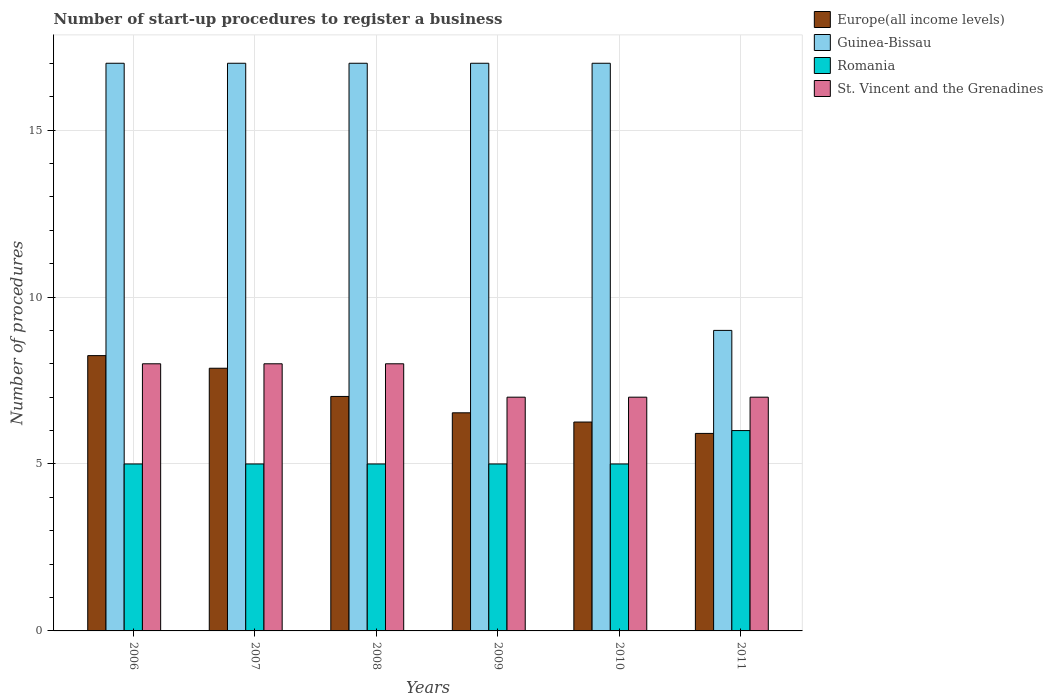How many groups of bars are there?
Provide a succinct answer. 6. Are the number of bars per tick equal to the number of legend labels?
Offer a terse response. Yes. How many bars are there on the 3rd tick from the left?
Make the answer very short. 4. In how many cases, is the number of bars for a given year not equal to the number of legend labels?
Offer a very short reply. 0. Across all years, what is the minimum number of procedures required to register a business in St. Vincent and the Grenadines?
Your answer should be very brief. 7. In which year was the number of procedures required to register a business in Europe(all income levels) maximum?
Make the answer very short. 2006. In which year was the number of procedures required to register a business in Romania minimum?
Your response must be concise. 2006. What is the difference between the number of procedures required to register a business in St. Vincent and the Grenadines in 2007 and that in 2009?
Your answer should be very brief. 1. What is the difference between the number of procedures required to register a business in Guinea-Bissau in 2007 and the number of procedures required to register a business in Europe(all income levels) in 2011?
Offer a terse response. 11.09. What is the average number of procedures required to register a business in Romania per year?
Offer a very short reply. 5.17. In the year 2007, what is the difference between the number of procedures required to register a business in Romania and number of procedures required to register a business in Europe(all income levels)?
Provide a succinct answer. -2.87. In how many years, is the number of procedures required to register a business in Romania greater than 8?
Offer a terse response. 0. What is the ratio of the number of procedures required to register a business in Romania in 2009 to that in 2011?
Keep it short and to the point. 0.83. What is the difference between the highest and the second highest number of procedures required to register a business in Europe(all income levels)?
Offer a terse response. 0.38. In how many years, is the number of procedures required to register a business in Europe(all income levels) greater than the average number of procedures required to register a business in Europe(all income levels) taken over all years?
Your response must be concise. 3. Is it the case that in every year, the sum of the number of procedures required to register a business in Europe(all income levels) and number of procedures required to register a business in Romania is greater than the sum of number of procedures required to register a business in Guinea-Bissau and number of procedures required to register a business in St. Vincent and the Grenadines?
Give a very brief answer. No. What does the 4th bar from the left in 2011 represents?
Your response must be concise. St. Vincent and the Grenadines. What does the 4th bar from the right in 2009 represents?
Offer a terse response. Europe(all income levels). Is it the case that in every year, the sum of the number of procedures required to register a business in Guinea-Bissau and number of procedures required to register a business in Romania is greater than the number of procedures required to register a business in Europe(all income levels)?
Your answer should be very brief. Yes. How many bars are there?
Make the answer very short. 24. What is the difference between two consecutive major ticks on the Y-axis?
Keep it short and to the point. 5. How many legend labels are there?
Give a very brief answer. 4. What is the title of the graph?
Provide a short and direct response. Number of start-up procedures to register a business. Does "Kazakhstan" appear as one of the legend labels in the graph?
Make the answer very short. No. What is the label or title of the Y-axis?
Offer a very short reply. Number of procedures. What is the Number of procedures of Europe(all income levels) in 2006?
Make the answer very short. 8.24. What is the Number of procedures of Romania in 2006?
Give a very brief answer. 5. What is the Number of procedures of Europe(all income levels) in 2007?
Make the answer very short. 7.87. What is the Number of procedures of Guinea-Bissau in 2007?
Give a very brief answer. 17. What is the Number of procedures in St. Vincent and the Grenadines in 2007?
Your answer should be compact. 8. What is the Number of procedures in Europe(all income levels) in 2008?
Keep it short and to the point. 7.02. What is the Number of procedures in Guinea-Bissau in 2008?
Ensure brevity in your answer.  17. What is the Number of procedures of St. Vincent and the Grenadines in 2008?
Provide a short and direct response. 8. What is the Number of procedures of Europe(all income levels) in 2009?
Ensure brevity in your answer.  6.53. What is the Number of procedures in Romania in 2009?
Ensure brevity in your answer.  5. What is the Number of procedures of Europe(all income levels) in 2010?
Your response must be concise. 6.26. What is the Number of procedures of Europe(all income levels) in 2011?
Give a very brief answer. 5.91. What is the Number of procedures of Guinea-Bissau in 2011?
Ensure brevity in your answer.  9. What is the Number of procedures in St. Vincent and the Grenadines in 2011?
Ensure brevity in your answer.  7. Across all years, what is the maximum Number of procedures of Europe(all income levels)?
Offer a terse response. 8.24. Across all years, what is the minimum Number of procedures in Europe(all income levels)?
Make the answer very short. 5.91. Across all years, what is the minimum Number of procedures in Romania?
Your answer should be very brief. 5. What is the total Number of procedures in Europe(all income levels) in the graph?
Provide a short and direct response. 41.84. What is the total Number of procedures in Guinea-Bissau in the graph?
Your answer should be very brief. 94. What is the total Number of procedures of St. Vincent and the Grenadines in the graph?
Keep it short and to the point. 45. What is the difference between the Number of procedures of Europe(all income levels) in 2006 and that in 2007?
Your response must be concise. 0.38. What is the difference between the Number of procedures of Guinea-Bissau in 2006 and that in 2007?
Your answer should be compact. 0. What is the difference between the Number of procedures of Romania in 2006 and that in 2007?
Your answer should be compact. 0. What is the difference between the Number of procedures in Europe(all income levels) in 2006 and that in 2008?
Offer a terse response. 1.22. What is the difference between the Number of procedures of St. Vincent and the Grenadines in 2006 and that in 2008?
Make the answer very short. 0. What is the difference between the Number of procedures in Europe(all income levels) in 2006 and that in 2009?
Make the answer very short. 1.71. What is the difference between the Number of procedures of Romania in 2006 and that in 2009?
Your answer should be compact. 0. What is the difference between the Number of procedures in Europe(all income levels) in 2006 and that in 2010?
Provide a short and direct response. 1.99. What is the difference between the Number of procedures in Romania in 2006 and that in 2010?
Ensure brevity in your answer.  0. What is the difference between the Number of procedures in St. Vincent and the Grenadines in 2006 and that in 2010?
Your answer should be compact. 1. What is the difference between the Number of procedures in Europe(all income levels) in 2006 and that in 2011?
Provide a short and direct response. 2.33. What is the difference between the Number of procedures of Romania in 2006 and that in 2011?
Your answer should be compact. -1. What is the difference between the Number of procedures of Europe(all income levels) in 2007 and that in 2008?
Your answer should be compact. 0.84. What is the difference between the Number of procedures in Guinea-Bissau in 2007 and that in 2008?
Your answer should be very brief. 0. What is the difference between the Number of procedures of Romania in 2007 and that in 2008?
Keep it short and to the point. 0. What is the difference between the Number of procedures in St. Vincent and the Grenadines in 2007 and that in 2008?
Provide a succinct answer. 0. What is the difference between the Number of procedures in Europe(all income levels) in 2007 and that in 2009?
Provide a short and direct response. 1.33. What is the difference between the Number of procedures of Guinea-Bissau in 2007 and that in 2009?
Offer a terse response. 0. What is the difference between the Number of procedures of Romania in 2007 and that in 2009?
Offer a very short reply. 0. What is the difference between the Number of procedures of Europe(all income levels) in 2007 and that in 2010?
Make the answer very short. 1.61. What is the difference between the Number of procedures of Europe(all income levels) in 2007 and that in 2011?
Offer a very short reply. 1.95. What is the difference between the Number of procedures of Guinea-Bissau in 2007 and that in 2011?
Your answer should be compact. 8. What is the difference between the Number of procedures in Europe(all income levels) in 2008 and that in 2009?
Your answer should be compact. 0.49. What is the difference between the Number of procedures of Guinea-Bissau in 2008 and that in 2009?
Give a very brief answer. 0. What is the difference between the Number of procedures of Romania in 2008 and that in 2009?
Provide a short and direct response. 0. What is the difference between the Number of procedures in Europe(all income levels) in 2008 and that in 2010?
Provide a short and direct response. 0.77. What is the difference between the Number of procedures in Romania in 2008 and that in 2010?
Make the answer very short. 0. What is the difference between the Number of procedures of St. Vincent and the Grenadines in 2008 and that in 2010?
Give a very brief answer. 1. What is the difference between the Number of procedures of Europe(all income levels) in 2008 and that in 2011?
Provide a succinct answer. 1.11. What is the difference between the Number of procedures in St. Vincent and the Grenadines in 2008 and that in 2011?
Give a very brief answer. 1. What is the difference between the Number of procedures in Europe(all income levels) in 2009 and that in 2010?
Your answer should be very brief. 0.28. What is the difference between the Number of procedures of St. Vincent and the Grenadines in 2009 and that in 2010?
Your response must be concise. 0. What is the difference between the Number of procedures in Europe(all income levels) in 2009 and that in 2011?
Make the answer very short. 0.62. What is the difference between the Number of procedures in Guinea-Bissau in 2009 and that in 2011?
Offer a terse response. 8. What is the difference between the Number of procedures of St. Vincent and the Grenadines in 2009 and that in 2011?
Offer a very short reply. 0. What is the difference between the Number of procedures of Europe(all income levels) in 2010 and that in 2011?
Offer a terse response. 0.34. What is the difference between the Number of procedures in Guinea-Bissau in 2010 and that in 2011?
Offer a terse response. 8. What is the difference between the Number of procedures in Romania in 2010 and that in 2011?
Your response must be concise. -1. What is the difference between the Number of procedures of Europe(all income levels) in 2006 and the Number of procedures of Guinea-Bissau in 2007?
Your answer should be compact. -8.76. What is the difference between the Number of procedures of Europe(all income levels) in 2006 and the Number of procedures of Romania in 2007?
Provide a short and direct response. 3.24. What is the difference between the Number of procedures in Europe(all income levels) in 2006 and the Number of procedures in St. Vincent and the Grenadines in 2007?
Offer a very short reply. 0.24. What is the difference between the Number of procedures in Guinea-Bissau in 2006 and the Number of procedures in Romania in 2007?
Offer a terse response. 12. What is the difference between the Number of procedures in Romania in 2006 and the Number of procedures in St. Vincent and the Grenadines in 2007?
Provide a succinct answer. -3. What is the difference between the Number of procedures of Europe(all income levels) in 2006 and the Number of procedures of Guinea-Bissau in 2008?
Give a very brief answer. -8.76. What is the difference between the Number of procedures in Europe(all income levels) in 2006 and the Number of procedures in Romania in 2008?
Give a very brief answer. 3.24. What is the difference between the Number of procedures in Europe(all income levels) in 2006 and the Number of procedures in St. Vincent and the Grenadines in 2008?
Your response must be concise. 0.24. What is the difference between the Number of procedures in Guinea-Bissau in 2006 and the Number of procedures in Romania in 2008?
Offer a terse response. 12. What is the difference between the Number of procedures of Romania in 2006 and the Number of procedures of St. Vincent and the Grenadines in 2008?
Make the answer very short. -3. What is the difference between the Number of procedures in Europe(all income levels) in 2006 and the Number of procedures in Guinea-Bissau in 2009?
Your answer should be very brief. -8.76. What is the difference between the Number of procedures in Europe(all income levels) in 2006 and the Number of procedures in Romania in 2009?
Provide a short and direct response. 3.24. What is the difference between the Number of procedures of Europe(all income levels) in 2006 and the Number of procedures of St. Vincent and the Grenadines in 2009?
Keep it short and to the point. 1.24. What is the difference between the Number of procedures of Romania in 2006 and the Number of procedures of St. Vincent and the Grenadines in 2009?
Offer a very short reply. -2. What is the difference between the Number of procedures of Europe(all income levels) in 2006 and the Number of procedures of Guinea-Bissau in 2010?
Give a very brief answer. -8.76. What is the difference between the Number of procedures of Europe(all income levels) in 2006 and the Number of procedures of Romania in 2010?
Make the answer very short. 3.24. What is the difference between the Number of procedures of Europe(all income levels) in 2006 and the Number of procedures of St. Vincent and the Grenadines in 2010?
Your response must be concise. 1.24. What is the difference between the Number of procedures of Guinea-Bissau in 2006 and the Number of procedures of Romania in 2010?
Your answer should be compact. 12. What is the difference between the Number of procedures in Guinea-Bissau in 2006 and the Number of procedures in St. Vincent and the Grenadines in 2010?
Your answer should be compact. 10. What is the difference between the Number of procedures of Romania in 2006 and the Number of procedures of St. Vincent and the Grenadines in 2010?
Offer a very short reply. -2. What is the difference between the Number of procedures of Europe(all income levels) in 2006 and the Number of procedures of Guinea-Bissau in 2011?
Provide a succinct answer. -0.76. What is the difference between the Number of procedures in Europe(all income levels) in 2006 and the Number of procedures in Romania in 2011?
Provide a succinct answer. 2.24. What is the difference between the Number of procedures of Europe(all income levels) in 2006 and the Number of procedures of St. Vincent and the Grenadines in 2011?
Make the answer very short. 1.24. What is the difference between the Number of procedures in Romania in 2006 and the Number of procedures in St. Vincent and the Grenadines in 2011?
Ensure brevity in your answer.  -2. What is the difference between the Number of procedures of Europe(all income levels) in 2007 and the Number of procedures of Guinea-Bissau in 2008?
Your response must be concise. -9.13. What is the difference between the Number of procedures in Europe(all income levels) in 2007 and the Number of procedures in Romania in 2008?
Make the answer very short. 2.87. What is the difference between the Number of procedures in Europe(all income levels) in 2007 and the Number of procedures in St. Vincent and the Grenadines in 2008?
Make the answer very short. -0.13. What is the difference between the Number of procedures in Guinea-Bissau in 2007 and the Number of procedures in Romania in 2008?
Give a very brief answer. 12. What is the difference between the Number of procedures in Romania in 2007 and the Number of procedures in St. Vincent and the Grenadines in 2008?
Ensure brevity in your answer.  -3. What is the difference between the Number of procedures in Europe(all income levels) in 2007 and the Number of procedures in Guinea-Bissau in 2009?
Keep it short and to the point. -9.13. What is the difference between the Number of procedures of Europe(all income levels) in 2007 and the Number of procedures of Romania in 2009?
Provide a succinct answer. 2.87. What is the difference between the Number of procedures in Europe(all income levels) in 2007 and the Number of procedures in St. Vincent and the Grenadines in 2009?
Make the answer very short. 0.87. What is the difference between the Number of procedures in Guinea-Bissau in 2007 and the Number of procedures in Romania in 2009?
Ensure brevity in your answer.  12. What is the difference between the Number of procedures of Romania in 2007 and the Number of procedures of St. Vincent and the Grenadines in 2009?
Make the answer very short. -2. What is the difference between the Number of procedures in Europe(all income levels) in 2007 and the Number of procedures in Guinea-Bissau in 2010?
Your answer should be very brief. -9.13. What is the difference between the Number of procedures in Europe(all income levels) in 2007 and the Number of procedures in Romania in 2010?
Give a very brief answer. 2.87. What is the difference between the Number of procedures in Europe(all income levels) in 2007 and the Number of procedures in St. Vincent and the Grenadines in 2010?
Make the answer very short. 0.87. What is the difference between the Number of procedures in Guinea-Bissau in 2007 and the Number of procedures in Romania in 2010?
Your answer should be compact. 12. What is the difference between the Number of procedures in Guinea-Bissau in 2007 and the Number of procedures in St. Vincent and the Grenadines in 2010?
Provide a short and direct response. 10. What is the difference between the Number of procedures of Europe(all income levels) in 2007 and the Number of procedures of Guinea-Bissau in 2011?
Ensure brevity in your answer.  -1.13. What is the difference between the Number of procedures in Europe(all income levels) in 2007 and the Number of procedures in Romania in 2011?
Make the answer very short. 1.87. What is the difference between the Number of procedures of Europe(all income levels) in 2007 and the Number of procedures of St. Vincent and the Grenadines in 2011?
Offer a very short reply. 0.87. What is the difference between the Number of procedures of Guinea-Bissau in 2007 and the Number of procedures of Romania in 2011?
Your answer should be very brief. 11. What is the difference between the Number of procedures of Romania in 2007 and the Number of procedures of St. Vincent and the Grenadines in 2011?
Your answer should be very brief. -2. What is the difference between the Number of procedures in Europe(all income levels) in 2008 and the Number of procedures in Guinea-Bissau in 2009?
Give a very brief answer. -9.98. What is the difference between the Number of procedures in Europe(all income levels) in 2008 and the Number of procedures in Romania in 2009?
Keep it short and to the point. 2.02. What is the difference between the Number of procedures in Europe(all income levels) in 2008 and the Number of procedures in St. Vincent and the Grenadines in 2009?
Make the answer very short. 0.02. What is the difference between the Number of procedures in Guinea-Bissau in 2008 and the Number of procedures in Romania in 2009?
Provide a short and direct response. 12. What is the difference between the Number of procedures in Europe(all income levels) in 2008 and the Number of procedures in Guinea-Bissau in 2010?
Your answer should be compact. -9.98. What is the difference between the Number of procedures of Europe(all income levels) in 2008 and the Number of procedures of Romania in 2010?
Ensure brevity in your answer.  2.02. What is the difference between the Number of procedures in Europe(all income levels) in 2008 and the Number of procedures in St. Vincent and the Grenadines in 2010?
Give a very brief answer. 0.02. What is the difference between the Number of procedures of Europe(all income levels) in 2008 and the Number of procedures of Guinea-Bissau in 2011?
Provide a short and direct response. -1.98. What is the difference between the Number of procedures in Europe(all income levels) in 2008 and the Number of procedures in Romania in 2011?
Keep it short and to the point. 1.02. What is the difference between the Number of procedures in Europe(all income levels) in 2008 and the Number of procedures in St. Vincent and the Grenadines in 2011?
Your answer should be very brief. 0.02. What is the difference between the Number of procedures of Romania in 2008 and the Number of procedures of St. Vincent and the Grenadines in 2011?
Provide a short and direct response. -2. What is the difference between the Number of procedures of Europe(all income levels) in 2009 and the Number of procedures of Guinea-Bissau in 2010?
Give a very brief answer. -10.47. What is the difference between the Number of procedures of Europe(all income levels) in 2009 and the Number of procedures of Romania in 2010?
Keep it short and to the point. 1.53. What is the difference between the Number of procedures of Europe(all income levels) in 2009 and the Number of procedures of St. Vincent and the Grenadines in 2010?
Provide a short and direct response. -0.47. What is the difference between the Number of procedures of Guinea-Bissau in 2009 and the Number of procedures of Romania in 2010?
Offer a terse response. 12. What is the difference between the Number of procedures of Europe(all income levels) in 2009 and the Number of procedures of Guinea-Bissau in 2011?
Provide a short and direct response. -2.47. What is the difference between the Number of procedures of Europe(all income levels) in 2009 and the Number of procedures of Romania in 2011?
Your answer should be very brief. 0.53. What is the difference between the Number of procedures of Europe(all income levels) in 2009 and the Number of procedures of St. Vincent and the Grenadines in 2011?
Your answer should be compact. -0.47. What is the difference between the Number of procedures in Europe(all income levels) in 2010 and the Number of procedures in Guinea-Bissau in 2011?
Provide a short and direct response. -2.74. What is the difference between the Number of procedures in Europe(all income levels) in 2010 and the Number of procedures in Romania in 2011?
Your answer should be very brief. 0.26. What is the difference between the Number of procedures in Europe(all income levels) in 2010 and the Number of procedures in St. Vincent and the Grenadines in 2011?
Ensure brevity in your answer.  -0.74. What is the difference between the Number of procedures in Guinea-Bissau in 2010 and the Number of procedures in Romania in 2011?
Provide a succinct answer. 11. What is the average Number of procedures in Europe(all income levels) per year?
Provide a short and direct response. 6.97. What is the average Number of procedures of Guinea-Bissau per year?
Offer a terse response. 15.67. What is the average Number of procedures in Romania per year?
Your response must be concise. 5.17. In the year 2006, what is the difference between the Number of procedures in Europe(all income levels) and Number of procedures in Guinea-Bissau?
Your answer should be very brief. -8.76. In the year 2006, what is the difference between the Number of procedures in Europe(all income levels) and Number of procedures in Romania?
Your response must be concise. 3.24. In the year 2006, what is the difference between the Number of procedures in Europe(all income levels) and Number of procedures in St. Vincent and the Grenadines?
Offer a terse response. 0.24. In the year 2006, what is the difference between the Number of procedures in Guinea-Bissau and Number of procedures in Romania?
Offer a terse response. 12. In the year 2006, what is the difference between the Number of procedures of Guinea-Bissau and Number of procedures of St. Vincent and the Grenadines?
Keep it short and to the point. 9. In the year 2006, what is the difference between the Number of procedures in Romania and Number of procedures in St. Vincent and the Grenadines?
Provide a succinct answer. -3. In the year 2007, what is the difference between the Number of procedures of Europe(all income levels) and Number of procedures of Guinea-Bissau?
Offer a terse response. -9.13. In the year 2007, what is the difference between the Number of procedures of Europe(all income levels) and Number of procedures of Romania?
Ensure brevity in your answer.  2.87. In the year 2007, what is the difference between the Number of procedures in Europe(all income levels) and Number of procedures in St. Vincent and the Grenadines?
Your answer should be very brief. -0.13. In the year 2007, what is the difference between the Number of procedures of Guinea-Bissau and Number of procedures of St. Vincent and the Grenadines?
Your answer should be very brief. 9. In the year 2008, what is the difference between the Number of procedures in Europe(all income levels) and Number of procedures in Guinea-Bissau?
Your response must be concise. -9.98. In the year 2008, what is the difference between the Number of procedures of Europe(all income levels) and Number of procedures of Romania?
Your answer should be compact. 2.02. In the year 2008, what is the difference between the Number of procedures of Europe(all income levels) and Number of procedures of St. Vincent and the Grenadines?
Your answer should be very brief. -0.98. In the year 2008, what is the difference between the Number of procedures in Romania and Number of procedures in St. Vincent and the Grenadines?
Your answer should be compact. -3. In the year 2009, what is the difference between the Number of procedures in Europe(all income levels) and Number of procedures in Guinea-Bissau?
Offer a very short reply. -10.47. In the year 2009, what is the difference between the Number of procedures of Europe(all income levels) and Number of procedures of Romania?
Provide a succinct answer. 1.53. In the year 2009, what is the difference between the Number of procedures in Europe(all income levels) and Number of procedures in St. Vincent and the Grenadines?
Make the answer very short. -0.47. In the year 2009, what is the difference between the Number of procedures of Guinea-Bissau and Number of procedures of Romania?
Provide a short and direct response. 12. In the year 2009, what is the difference between the Number of procedures in Guinea-Bissau and Number of procedures in St. Vincent and the Grenadines?
Keep it short and to the point. 10. In the year 2010, what is the difference between the Number of procedures in Europe(all income levels) and Number of procedures in Guinea-Bissau?
Provide a succinct answer. -10.74. In the year 2010, what is the difference between the Number of procedures of Europe(all income levels) and Number of procedures of Romania?
Provide a succinct answer. 1.26. In the year 2010, what is the difference between the Number of procedures in Europe(all income levels) and Number of procedures in St. Vincent and the Grenadines?
Your response must be concise. -0.74. In the year 2010, what is the difference between the Number of procedures in Guinea-Bissau and Number of procedures in Romania?
Make the answer very short. 12. In the year 2010, what is the difference between the Number of procedures of Guinea-Bissau and Number of procedures of St. Vincent and the Grenadines?
Make the answer very short. 10. In the year 2010, what is the difference between the Number of procedures in Romania and Number of procedures in St. Vincent and the Grenadines?
Ensure brevity in your answer.  -2. In the year 2011, what is the difference between the Number of procedures in Europe(all income levels) and Number of procedures in Guinea-Bissau?
Keep it short and to the point. -3.09. In the year 2011, what is the difference between the Number of procedures of Europe(all income levels) and Number of procedures of Romania?
Offer a terse response. -0.09. In the year 2011, what is the difference between the Number of procedures of Europe(all income levels) and Number of procedures of St. Vincent and the Grenadines?
Keep it short and to the point. -1.09. In the year 2011, what is the difference between the Number of procedures in Guinea-Bissau and Number of procedures in Romania?
Offer a terse response. 3. In the year 2011, what is the difference between the Number of procedures in Romania and Number of procedures in St. Vincent and the Grenadines?
Your answer should be very brief. -1. What is the ratio of the Number of procedures in Europe(all income levels) in 2006 to that in 2007?
Your answer should be compact. 1.05. What is the ratio of the Number of procedures of Europe(all income levels) in 2006 to that in 2008?
Ensure brevity in your answer.  1.17. What is the ratio of the Number of procedures in Romania in 2006 to that in 2008?
Offer a terse response. 1. What is the ratio of the Number of procedures in St. Vincent and the Grenadines in 2006 to that in 2008?
Your answer should be compact. 1. What is the ratio of the Number of procedures of Europe(all income levels) in 2006 to that in 2009?
Offer a very short reply. 1.26. What is the ratio of the Number of procedures in Europe(all income levels) in 2006 to that in 2010?
Provide a succinct answer. 1.32. What is the ratio of the Number of procedures in Guinea-Bissau in 2006 to that in 2010?
Keep it short and to the point. 1. What is the ratio of the Number of procedures of Europe(all income levels) in 2006 to that in 2011?
Your response must be concise. 1.39. What is the ratio of the Number of procedures of Guinea-Bissau in 2006 to that in 2011?
Offer a very short reply. 1.89. What is the ratio of the Number of procedures in Romania in 2006 to that in 2011?
Offer a terse response. 0.83. What is the ratio of the Number of procedures of St. Vincent and the Grenadines in 2006 to that in 2011?
Provide a succinct answer. 1.14. What is the ratio of the Number of procedures in Europe(all income levels) in 2007 to that in 2008?
Make the answer very short. 1.12. What is the ratio of the Number of procedures in Romania in 2007 to that in 2008?
Offer a very short reply. 1. What is the ratio of the Number of procedures of St. Vincent and the Grenadines in 2007 to that in 2008?
Give a very brief answer. 1. What is the ratio of the Number of procedures in Europe(all income levels) in 2007 to that in 2009?
Provide a succinct answer. 1.2. What is the ratio of the Number of procedures of St. Vincent and the Grenadines in 2007 to that in 2009?
Provide a succinct answer. 1.14. What is the ratio of the Number of procedures of Europe(all income levels) in 2007 to that in 2010?
Offer a very short reply. 1.26. What is the ratio of the Number of procedures of St. Vincent and the Grenadines in 2007 to that in 2010?
Provide a short and direct response. 1.14. What is the ratio of the Number of procedures of Europe(all income levels) in 2007 to that in 2011?
Provide a short and direct response. 1.33. What is the ratio of the Number of procedures of Guinea-Bissau in 2007 to that in 2011?
Keep it short and to the point. 1.89. What is the ratio of the Number of procedures of Europe(all income levels) in 2008 to that in 2009?
Ensure brevity in your answer.  1.07. What is the ratio of the Number of procedures of Guinea-Bissau in 2008 to that in 2009?
Provide a short and direct response. 1. What is the ratio of the Number of procedures in Europe(all income levels) in 2008 to that in 2010?
Provide a succinct answer. 1.12. What is the ratio of the Number of procedures in Guinea-Bissau in 2008 to that in 2010?
Provide a short and direct response. 1. What is the ratio of the Number of procedures in Romania in 2008 to that in 2010?
Provide a short and direct response. 1. What is the ratio of the Number of procedures of Europe(all income levels) in 2008 to that in 2011?
Your answer should be very brief. 1.19. What is the ratio of the Number of procedures of Guinea-Bissau in 2008 to that in 2011?
Ensure brevity in your answer.  1.89. What is the ratio of the Number of procedures of Europe(all income levels) in 2009 to that in 2010?
Your answer should be compact. 1.04. What is the ratio of the Number of procedures in Romania in 2009 to that in 2010?
Your answer should be very brief. 1. What is the ratio of the Number of procedures of Europe(all income levels) in 2009 to that in 2011?
Offer a terse response. 1.1. What is the ratio of the Number of procedures of Guinea-Bissau in 2009 to that in 2011?
Your answer should be very brief. 1.89. What is the ratio of the Number of procedures of Europe(all income levels) in 2010 to that in 2011?
Your answer should be compact. 1.06. What is the ratio of the Number of procedures in Guinea-Bissau in 2010 to that in 2011?
Make the answer very short. 1.89. What is the difference between the highest and the second highest Number of procedures of Europe(all income levels)?
Your answer should be very brief. 0.38. What is the difference between the highest and the second highest Number of procedures in Guinea-Bissau?
Keep it short and to the point. 0. What is the difference between the highest and the second highest Number of procedures in Romania?
Your answer should be very brief. 1. What is the difference between the highest and the second highest Number of procedures in St. Vincent and the Grenadines?
Offer a terse response. 0. What is the difference between the highest and the lowest Number of procedures of Europe(all income levels)?
Provide a succinct answer. 2.33. 